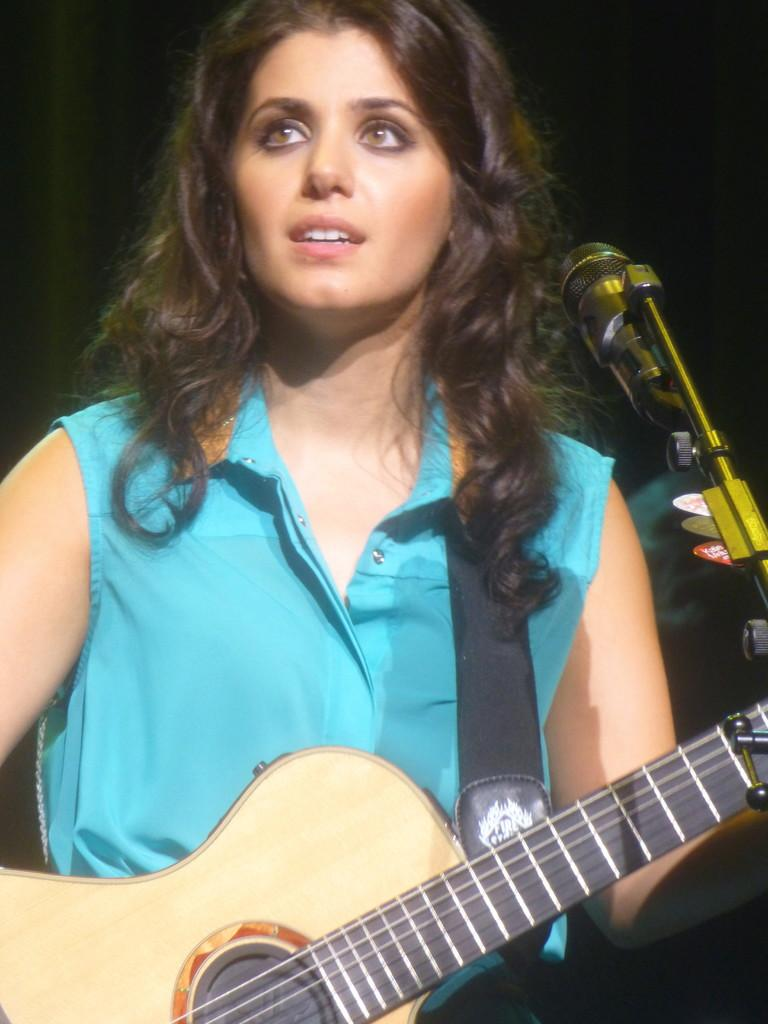Who is the main subject in the image? There is a girl in the image. Where is the girl located in the image? The girl is at the center of the image. What is the girl holding in the image? The girl is holding a guitar. What object is in front of the girl? There is a microphone in front of the girl. What type of fuel is the girl using to play the guitar in the image? There is no fuel involved in playing the guitar in the image; it is a musical instrument that does not require fuel. 